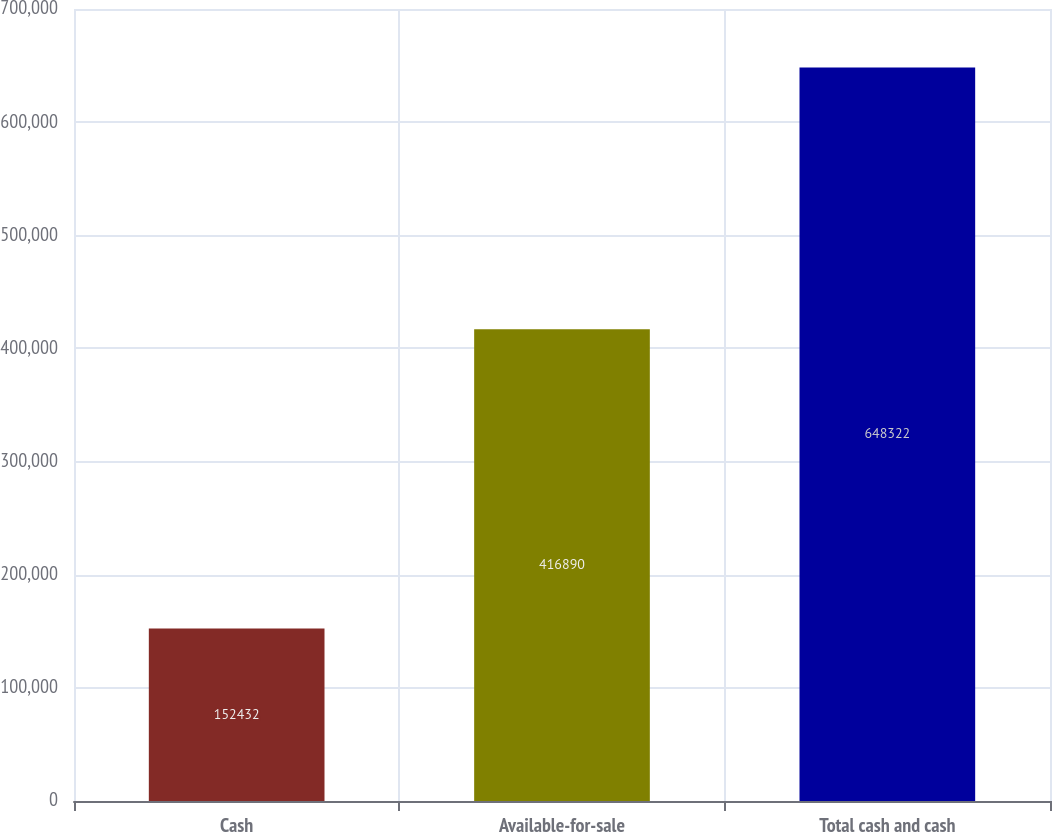Convert chart to OTSL. <chart><loc_0><loc_0><loc_500><loc_500><bar_chart><fcel>Cash<fcel>Available-for-sale<fcel>Total cash and cash<nl><fcel>152432<fcel>416890<fcel>648322<nl></chart> 